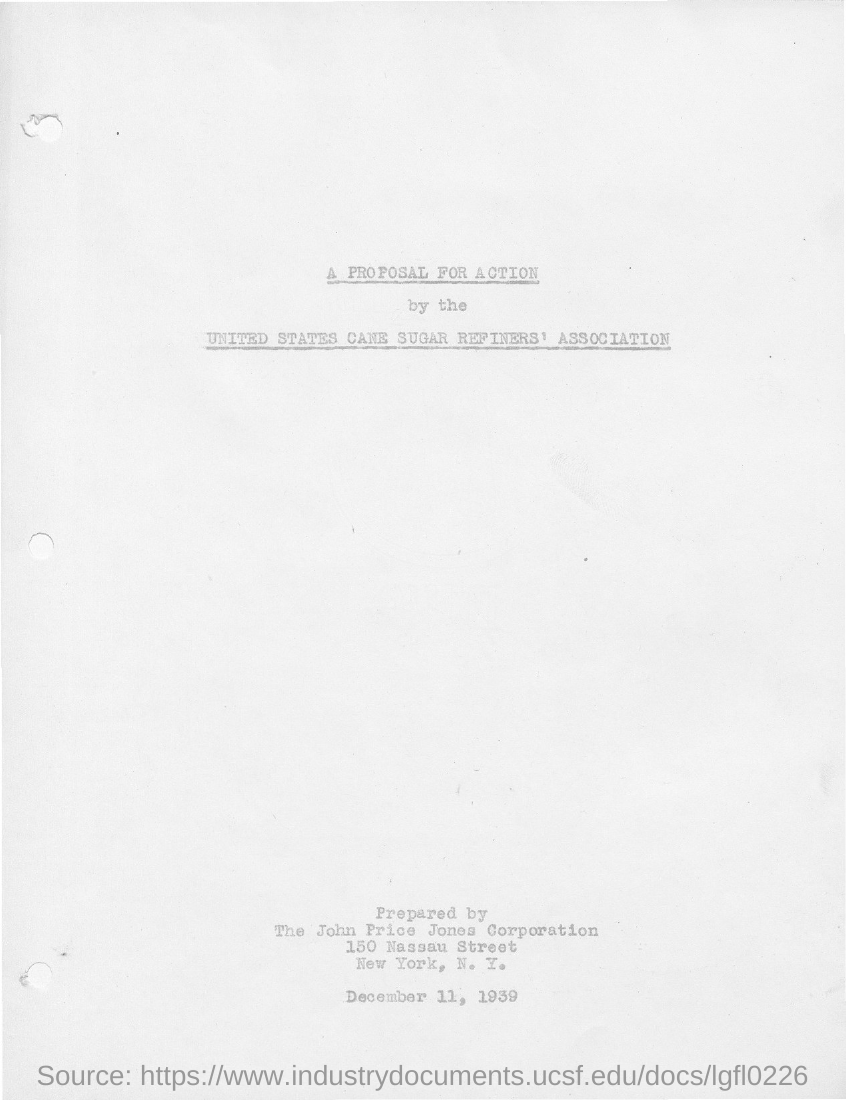Outline some significant characteristics in this image. The John Price Jones Corporation prepared the proposal for action by the United States Cane Sugar Refiners' Association. 